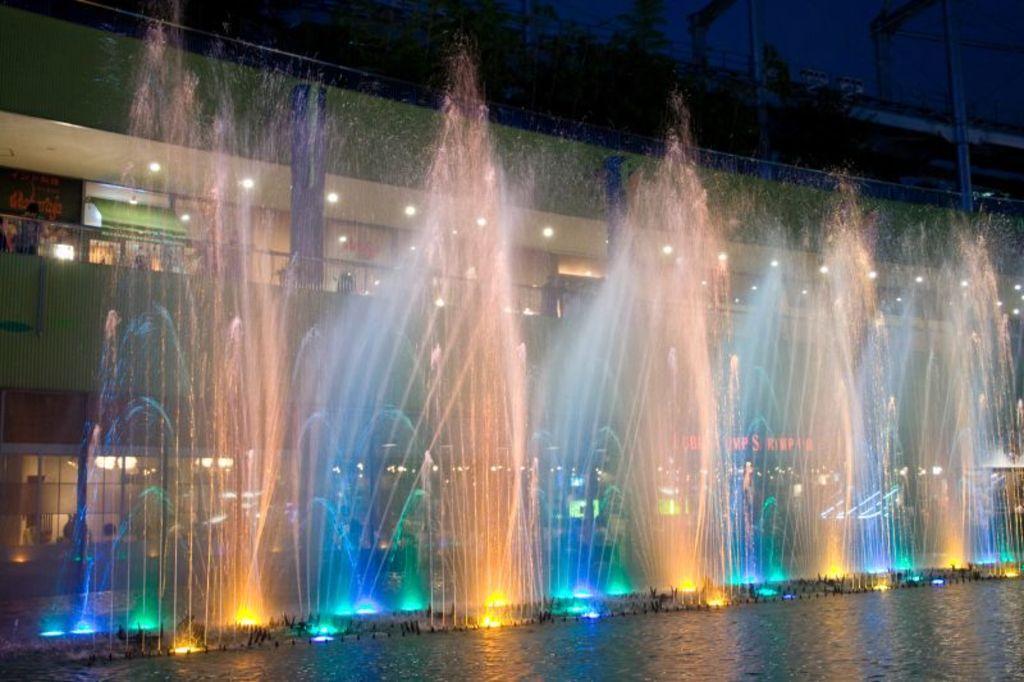Please provide a concise description of this image. At the bottom of the image there is water with fountains. Behind the fountains there is a building with walls, pillars and lights. 